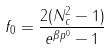<formula> <loc_0><loc_0><loc_500><loc_500>f _ { 0 } = \frac { 2 ( { N ^ { 2 } _ { c } } - 1 ) } { e ^ { \beta p ^ { 0 } } - 1 }</formula> 